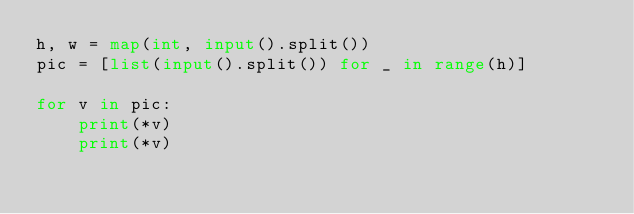Convert code to text. <code><loc_0><loc_0><loc_500><loc_500><_Python_>h, w = map(int, input().split())
pic = [list(input().split()) for _ in range(h)]

for v in pic:
    print(*v)
    print(*v)

</code> 